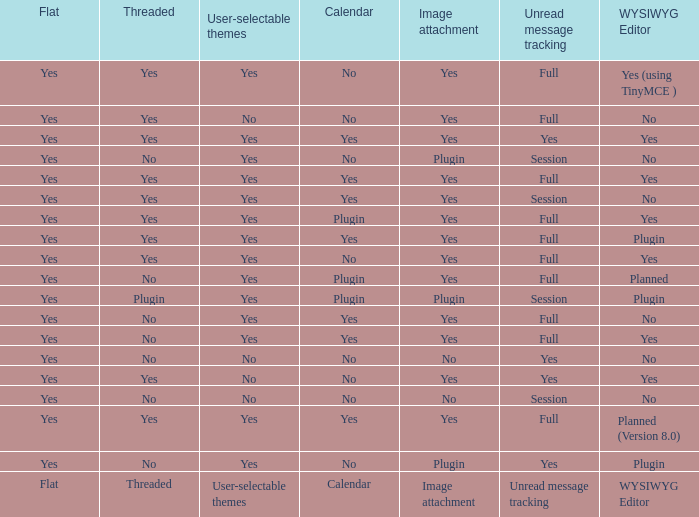Which calendar allows users to pick their desired themes from a selection of choices? Calendar. 